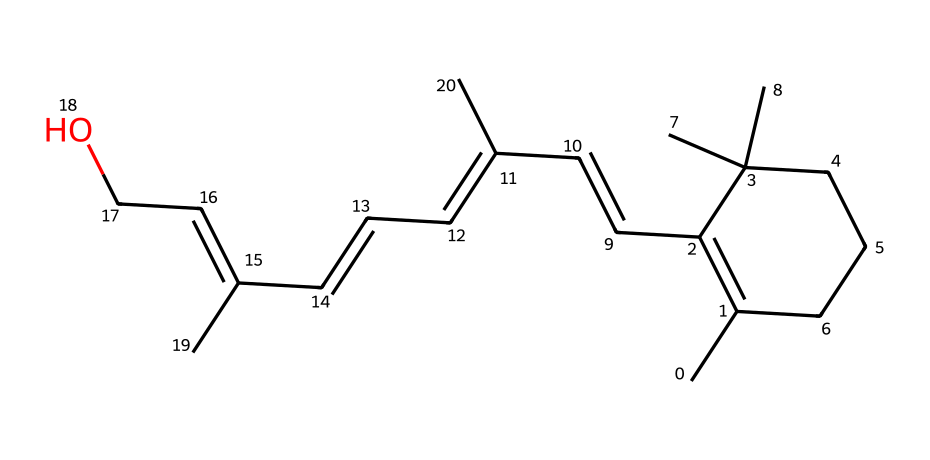how many carbon atoms are in the structure? To find the number of carbon atoms, we can count all the 'C' symbols in the SMILES representation. Each 'C' represents a carbon atom. By going through the structure, we can tally them, ensuring we count each unique carbon. The total count gives us the answer.
Answer: eighteen what is the maximum number of geometric isomers possible for this chemical? Geometric isomers occur due to the presence of double bonds and restricted rotation. In this structure, we have multiple double bonds (notably at various CC connections). The maximum number of geometric isomers can be determined by identifying the double bonds and analyzing the groups attached to them. For each double bond with two different substituents, two geometric isomers are possible (cis and trans). By considering the unique positions of the double bonds and the groups attached, we can determine the total possible geometric isomers.
Answer: eight which functional group is present in the chemical? Looking at the provided SMILES representation and the structural elements, we can notice the end segment 'CCO', which indicates the presence of an alcohol group (OH). This group is characteristic of alcohols. By identifying the unique features and functionality of the entire compound, we conclude the type of functional group present.
Answer: alcohol what is the specific name of the compound based on its structure? This compound is recognized as a form of vitamin A (retinol), which is pivotal for vision and skin health. By referring to established chemical nomenclature related to vitamins and analyzing the structure, we can identify and name the compound.
Answer: retinol does this compound have a cis or trans configuration? By examining the double bonds in the structure, we can determine their configuration. For any double bond, if the highest priority substituents on each carbon are on the same side, it is termed cis; if they are on opposite sides, it is trans. Evaluating the placement of substituents around the double bonds in the given SMILES, we can conclude the predominant configuration.
Answer: both what kind of isomerism does this structure exhibit? This chemical exhibits geometric isomerism, a form of stereoisomerism. Within the context of the structure, we can see the presence of double bonds, which allow for various configurations of the attached atoms/groups. By analyzing how these groups can vary while maintaining connectivity, we can conclusively identify the type of isomerism present.
Answer: geometric isomerism 